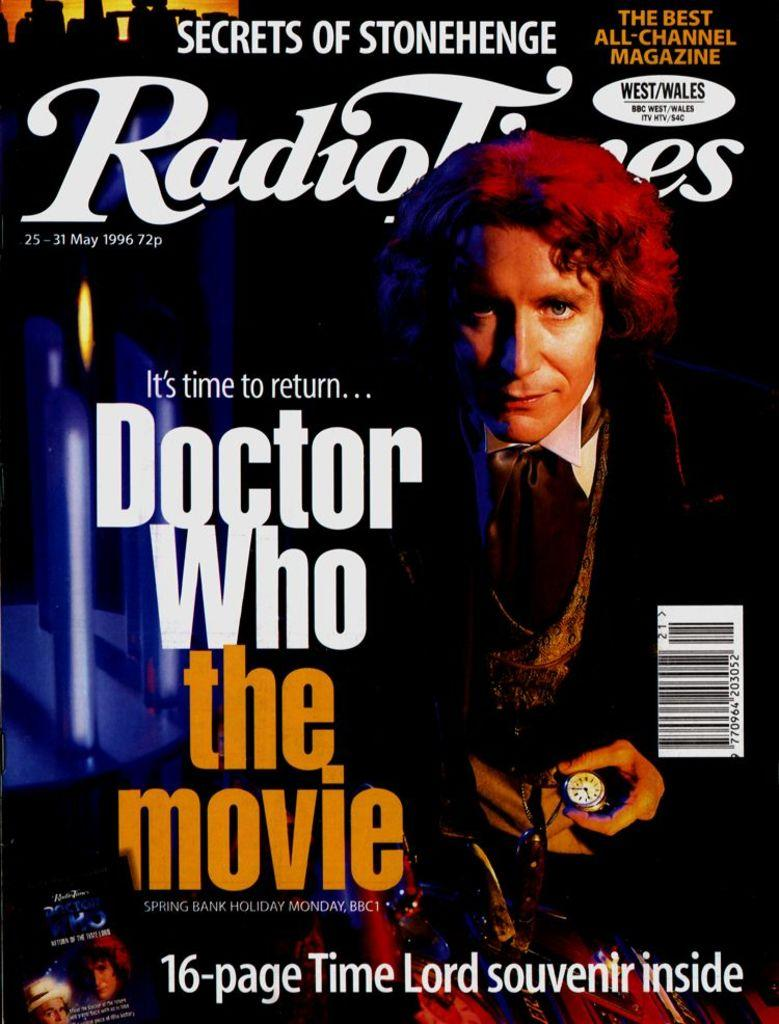<image>
Render a clear and concise summary of the photo. A magazine cover of Radio Tones that says 16 page souvenir inside. 